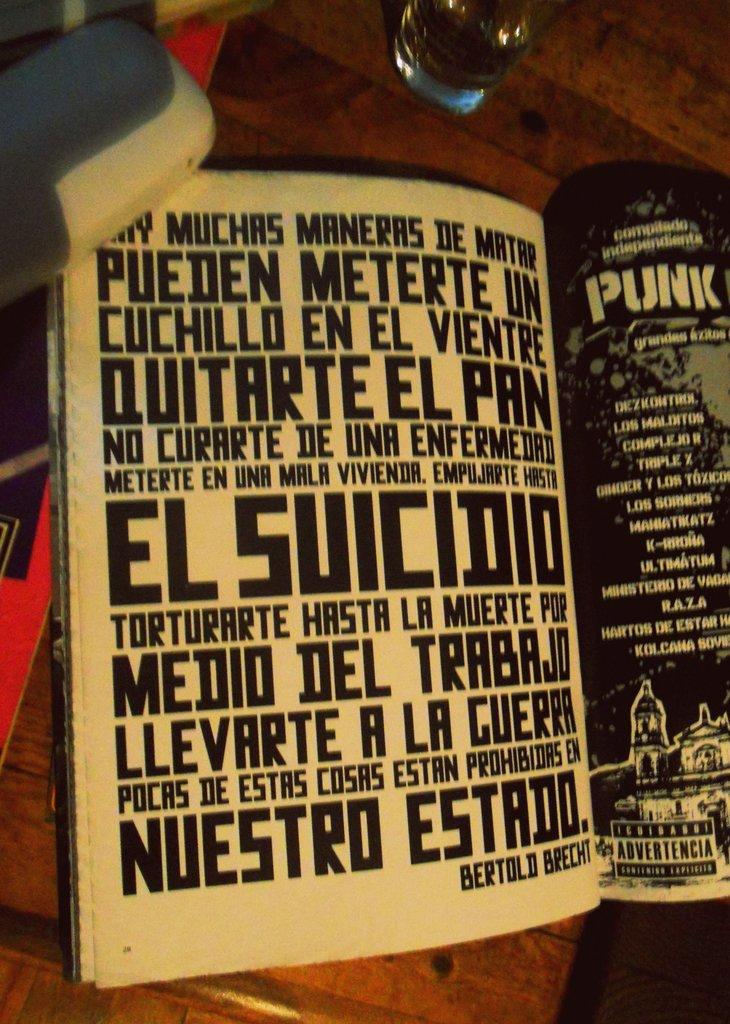Provide a one-sentence caption for the provided image. A quote in spanish about the many ways to die is advertised in a book. 